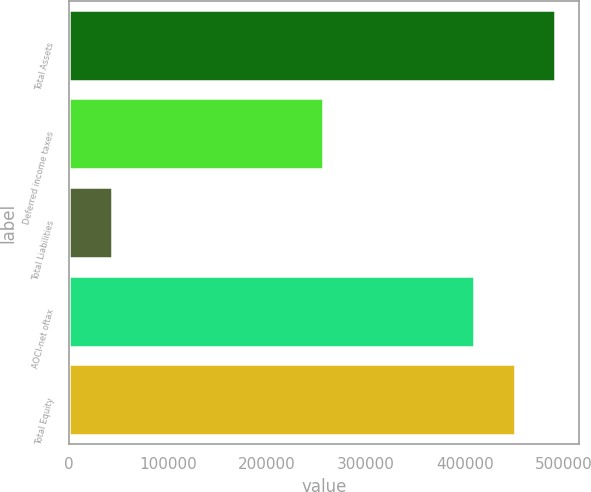Convert chart to OTSL. <chart><loc_0><loc_0><loc_500><loc_500><bar_chart><fcel>Total Assets<fcel>Deferred income taxes<fcel>Total Liabilities<fcel>AOCI-net oftax<fcel>Total Equity<nl><fcel>490988<fcel>256410<fcel>43315<fcel>409157<fcel>450073<nl></chart> 